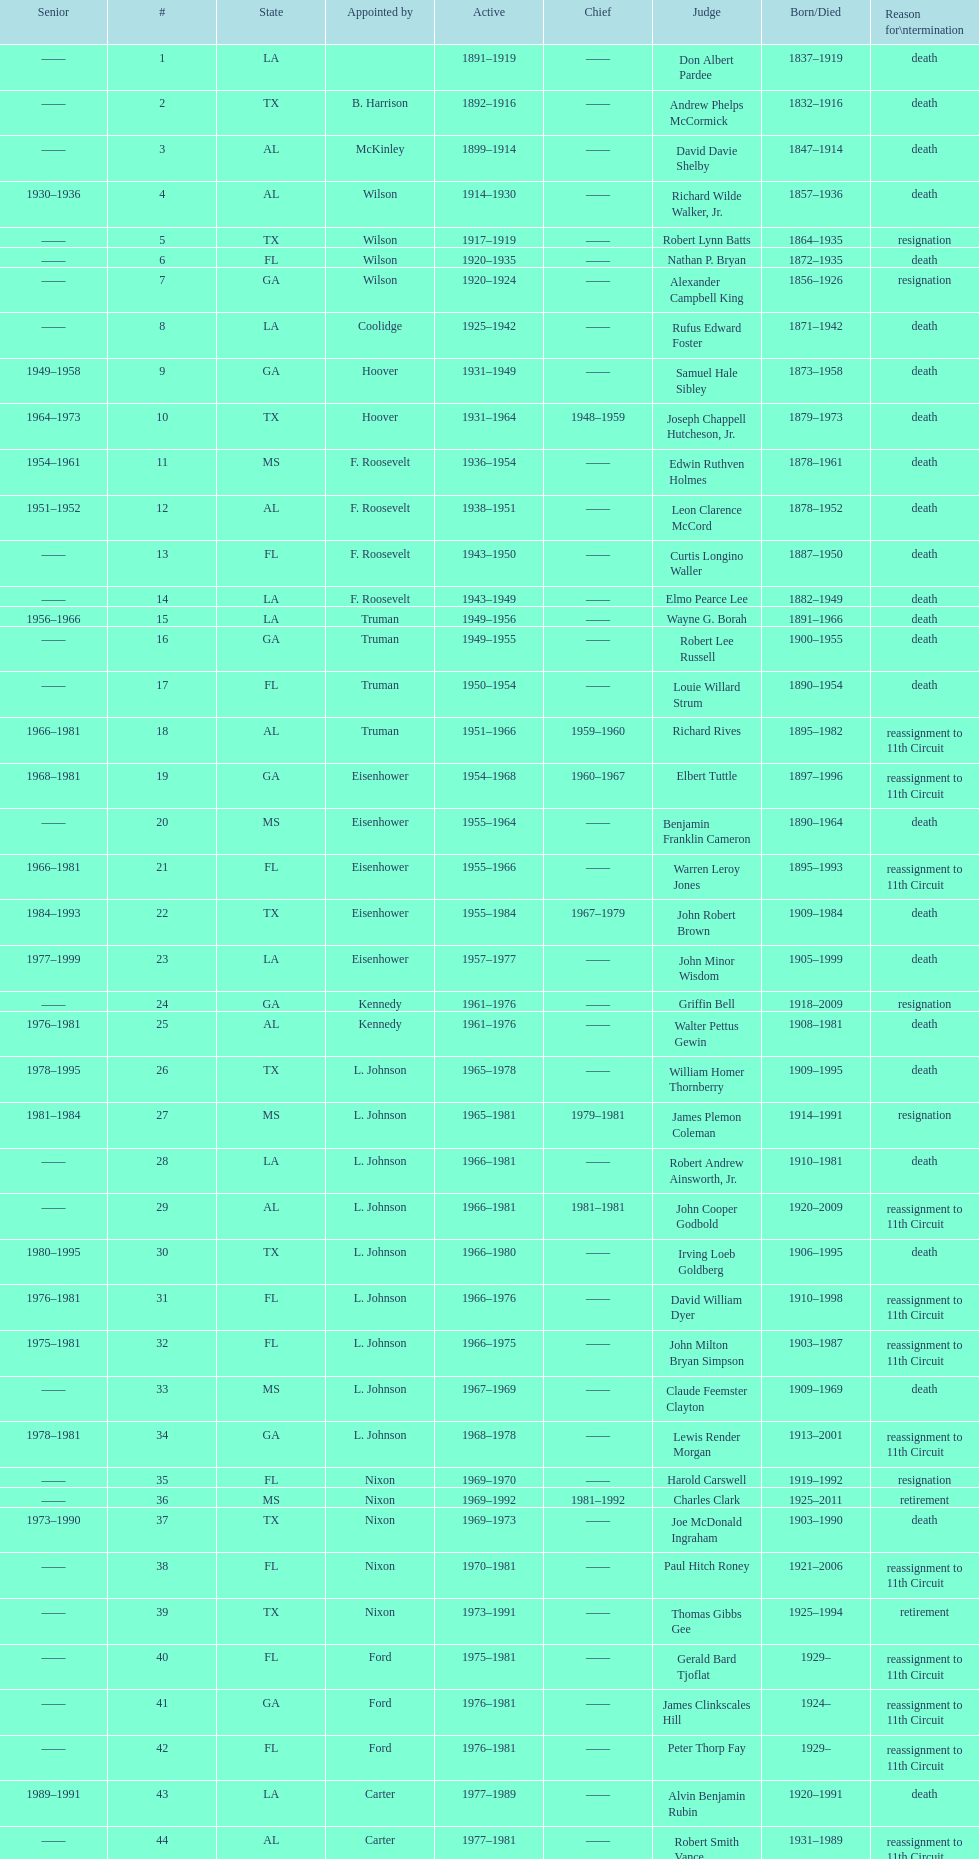Name a state listed at least 4 times. TX. Could you parse the entire table as a dict? {'header': ['Senior', '#', 'State', 'Appointed by', 'Active', 'Chief', 'Judge', 'Born/Died', 'Reason for\\ntermination'], 'rows': [['——', '1', 'LA', '', '1891–1919', '——', 'Don Albert Pardee', '1837–1919', 'death'], ['——', '2', 'TX', 'B. Harrison', '1892–1916', '——', 'Andrew Phelps McCormick', '1832–1916', 'death'], ['——', '3', 'AL', 'McKinley', '1899–1914', '——', 'David Davie Shelby', '1847–1914', 'death'], ['1930–1936', '4', 'AL', 'Wilson', '1914–1930', '——', 'Richard Wilde Walker, Jr.', '1857–1936', 'death'], ['——', '5', 'TX', 'Wilson', '1917–1919', '——', 'Robert Lynn Batts', '1864–1935', 'resignation'], ['——', '6', 'FL', 'Wilson', '1920–1935', '——', 'Nathan P. Bryan', '1872–1935', 'death'], ['——', '7', 'GA', 'Wilson', '1920–1924', '——', 'Alexander Campbell King', '1856–1926', 'resignation'], ['——', '8', 'LA', 'Coolidge', '1925–1942', '——', 'Rufus Edward Foster', '1871–1942', 'death'], ['1949–1958', '9', 'GA', 'Hoover', '1931–1949', '——', 'Samuel Hale Sibley', '1873–1958', 'death'], ['1964–1973', '10', 'TX', 'Hoover', '1931–1964', '1948–1959', 'Joseph Chappell Hutcheson, Jr.', '1879–1973', 'death'], ['1954–1961', '11', 'MS', 'F. Roosevelt', '1936–1954', '——', 'Edwin Ruthven Holmes', '1878–1961', 'death'], ['1951–1952', '12', 'AL', 'F. Roosevelt', '1938–1951', '——', 'Leon Clarence McCord', '1878–1952', 'death'], ['——', '13', 'FL', 'F. Roosevelt', '1943–1950', '——', 'Curtis Longino Waller', '1887–1950', 'death'], ['——', '14', 'LA', 'F. Roosevelt', '1943–1949', '——', 'Elmo Pearce Lee', '1882–1949', 'death'], ['1956–1966', '15', 'LA', 'Truman', '1949–1956', '——', 'Wayne G. Borah', '1891–1966', 'death'], ['——', '16', 'GA', 'Truman', '1949–1955', '——', 'Robert Lee Russell', '1900–1955', 'death'], ['——', '17', 'FL', 'Truman', '1950–1954', '——', 'Louie Willard Strum', '1890–1954', 'death'], ['1966–1981', '18', 'AL', 'Truman', '1951–1966', '1959–1960', 'Richard Rives', '1895–1982', 'reassignment to 11th Circuit'], ['1968–1981', '19', 'GA', 'Eisenhower', '1954–1968', '1960–1967', 'Elbert Tuttle', '1897–1996', 'reassignment to 11th Circuit'], ['——', '20', 'MS', 'Eisenhower', '1955–1964', '——', 'Benjamin Franklin Cameron', '1890–1964', 'death'], ['1966–1981', '21', 'FL', 'Eisenhower', '1955–1966', '——', 'Warren Leroy Jones', '1895–1993', 'reassignment to 11th Circuit'], ['1984–1993', '22', 'TX', 'Eisenhower', '1955–1984', '1967–1979', 'John Robert Brown', '1909–1984', 'death'], ['1977–1999', '23', 'LA', 'Eisenhower', '1957–1977', '——', 'John Minor Wisdom', '1905–1999', 'death'], ['——', '24', 'GA', 'Kennedy', '1961–1976', '——', 'Griffin Bell', '1918–2009', 'resignation'], ['1976–1981', '25', 'AL', 'Kennedy', '1961–1976', '——', 'Walter Pettus Gewin', '1908–1981', 'death'], ['1978–1995', '26', 'TX', 'L. Johnson', '1965–1978', '——', 'William Homer Thornberry', '1909–1995', 'death'], ['1981–1984', '27', 'MS', 'L. Johnson', '1965–1981', '1979–1981', 'James Plemon Coleman', '1914–1991', 'resignation'], ['——', '28', 'LA', 'L. Johnson', '1966–1981', '——', 'Robert Andrew Ainsworth, Jr.', '1910–1981', 'death'], ['——', '29', 'AL', 'L. Johnson', '1966–1981', '1981–1981', 'John Cooper Godbold', '1920–2009', 'reassignment to 11th Circuit'], ['1980–1995', '30', 'TX', 'L. Johnson', '1966–1980', '——', 'Irving Loeb Goldberg', '1906–1995', 'death'], ['1976–1981', '31', 'FL', 'L. Johnson', '1966–1976', '——', 'David William Dyer', '1910–1998', 'reassignment to 11th Circuit'], ['1975–1981', '32', 'FL', 'L. Johnson', '1966–1975', '——', 'John Milton Bryan Simpson', '1903–1987', 'reassignment to 11th Circuit'], ['——', '33', 'MS', 'L. Johnson', '1967–1969', '——', 'Claude Feemster Clayton', '1909–1969', 'death'], ['1978–1981', '34', 'GA', 'L. Johnson', '1968–1978', '——', 'Lewis Render Morgan', '1913–2001', 'reassignment to 11th Circuit'], ['——', '35', 'FL', 'Nixon', '1969–1970', '——', 'Harold Carswell', '1919–1992', 'resignation'], ['——', '36', 'MS', 'Nixon', '1969–1992', '1981–1992', 'Charles Clark', '1925–2011', 'retirement'], ['1973–1990', '37', 'TX', 'Nixon', '1969–1973', '——', 'Joe McDonald Ingraham', '1903–1990', 'death'], ['——', '38', 'FL', 'Nixon', '1970–1981', '——', 'Paul Hitch Roney', '1921–2006', 'reassignment to 11th Circuit'], ['——', '39', 'TX', 'Nixon', '1973–1991', '——', 'Thomas Gibbs Gee', '1925–1994', 'retirement'], ['——', '40', 'FL', 'Ford', '1975–1981', '——', 'Gerald Bard Tjoflat', '1929–', 'reassignment to 11th Circuit'], ['——', '41', 'GA', 'Ford', '1976–1981', '——', 'James Clinkscales Hill', '1924–', 'reassignment to 11th Circuit'], ['——', '42', 'FL', 'Ford', '1976–1981', '——', 'Peter Thorp Fay', '1929–', 'reassignment to 11th Circuit'], ['1989–1991', '43', 'LA', 'Carter', '1977–1989', '——', 'Alvin Benjamin Rubin', '1920–1991', 'death'], ['——', '44', 'AL', 'Carter', '1977–1981', '——', 'Robert Smith Vance', '1931–1989', 'reassignment to 11th Circuit'], ['——', '45', 'GA', 'Carter', '1979–1981', '——', 'Phyllis A. Kravitch', '1920–', 'reassignment to 11th Circuit'], ['——', '46', 'AL', 'Carter', '1979–1981', '——', 'Frank Minis Johnson', '1918–1999', 'reassignment to 11th Circuit'], ['——', '47', 'GA', 'Carter', '1979–1981', '——', 'R. Lanier Anderson III', '1936–', 'reassignment to 11th Circuit'], ['1982–2004', '48', 'TX', 'Carter', '1979–1982', '——', 'Reynaldo Guerra Garza', '1915–2004', 'death'], ['——', '49', 'FL', 'Carter', '1979–1981', '——', 'Joseph Woodrow Hatchett', '1932–', 'reassignment to 11th Circuit'], ['——', '50', 'GA', 'Carter', '1979–1981', '——', 'Albert John Henderson', '1920–1999', 'reassignment to 11th Circuit'], ['1999–2002', '52', 'LA', 'Carter', '1979–1999', '1992–1999', 'Henry Anthony Politz', '1932–2002', 'death'], ['1991–2002', '54', 'TX', 'Carter', '1979–1991', '——', 'Samuel D. Johnson, Jr.', '1920–2002', 'death'], ['——', '55', 'LA', 'Carter', '1979–1986', '——', 'Albert Tate, Jr.', '1920–1986', 'death'], ['——', '56', 'GA', 'Carter', '1979–1981', '——', 'Thomas Alonzo Clark', '1920–2005', 'reassignment to 11th Circuit'], ['1990–1993', '57', 'TX', 'Carter', '1980–1990', '——', 'Jerre Stockton Williams', '1916–1993', 'death'], ['1997–2011', '58', 'TX', 'Reagan', '1981–1997', '——', 'William Lockhart Garwood', '1931–2011', 'death'], ['——', '62', 'TX', 'Reagan', '1984–1987', '——', 'Robert Madden Hill', '1928–1987', 'death'], ['1999–2011', '65', 'LA', 'Reagan', '1988–1999', '——', 'John Malcolm Duhé, Jr.', '1933-', 'retirement'], ['——', '72', 'TX', 'Clinton', '1994–2002', '——', 'Robert Manley Parker', '1937–', 'retirement'], ['——', '76', 'MS', 'G.W. Bush', '2004–2004', '——', 'Charles W. Pickering', '1937–', 'retirement']]} 